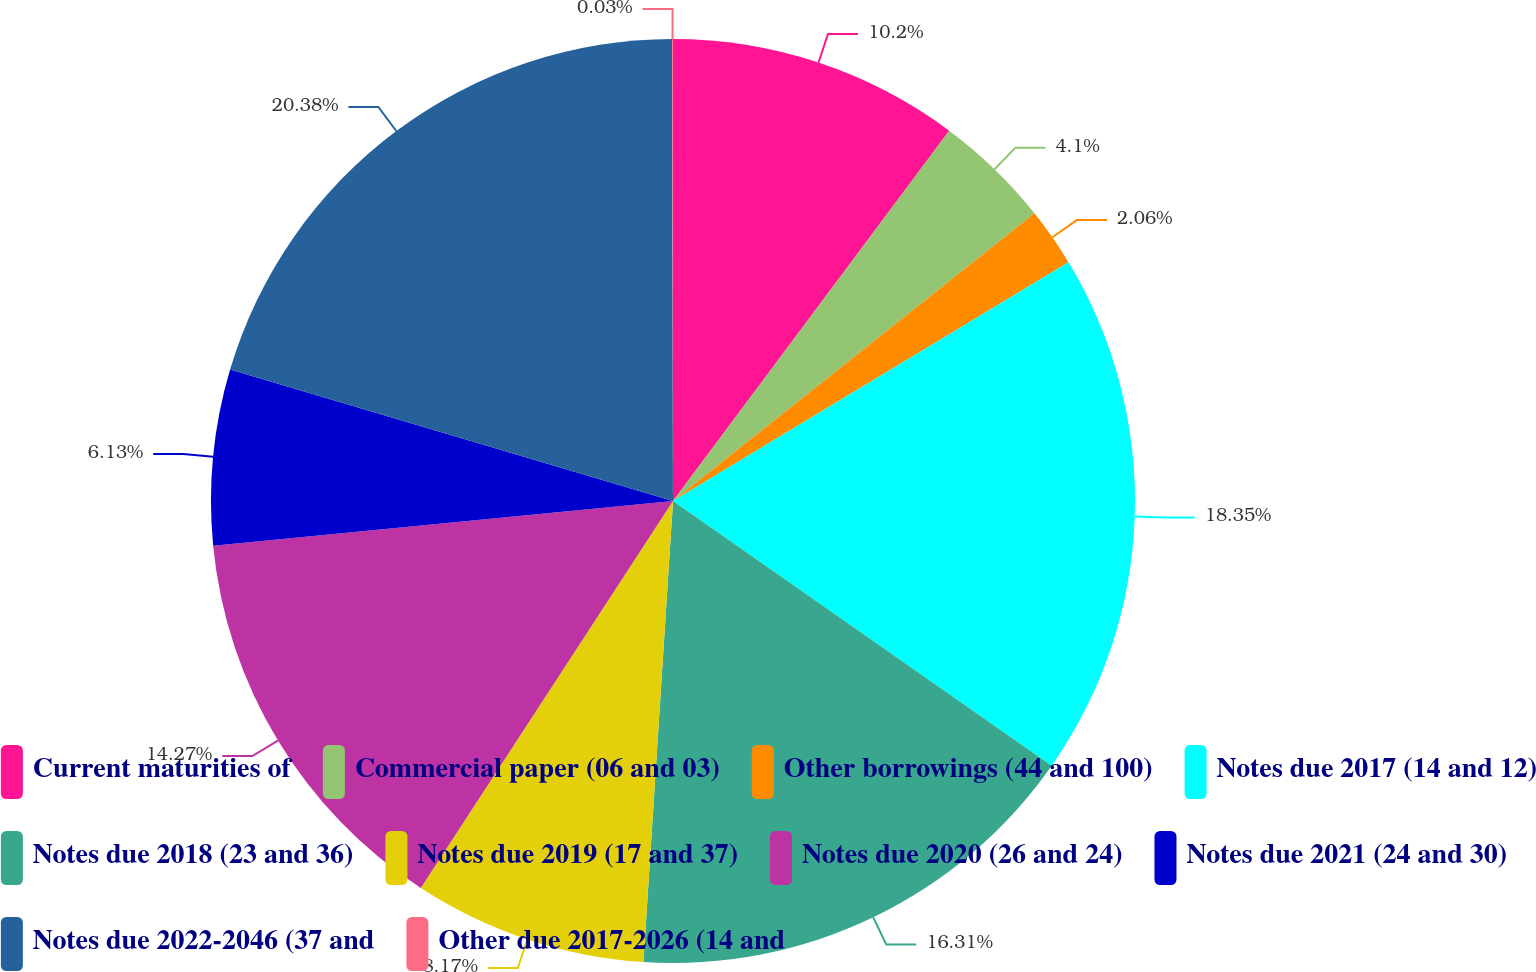Convert chart. <chart><loc_0><loc_0><loc_500><loc_500><pie_chart><fcel>Current maturities of<fcel>Commercial paper (06 and 03)<fcel>Other borrowings (44 and 100)<fcel>Notes due 2017 (14 and 12)<fcel>Notes due 2018 (23 and 36)<fcel>Notes due 2019 (17 and 37)<fcel>Notes due 2020 (26 and 24)<fcel>Notes due 2021 (24 and 30)<fcel>Notes due 2022-2046 (37 and<fcel>Other due 2017-2026 (14 and<nl><fcel>10.2%<fcel>4.1%<fcel>2.06%<fcel>18.35%<fcel>16.31%<fcel>8.17%<fcel>14.27%<fcel>6.13%<fcel>20.38%<fcel>0.03%<nl></chart> 